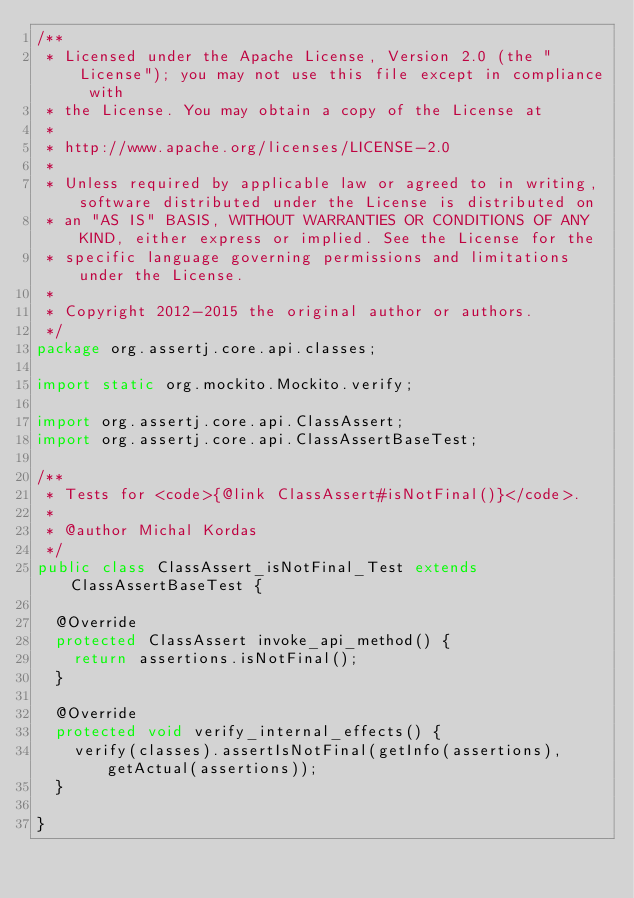Convert code to text. <code><loc_0><loc_0><loc_500><loc_500><_Java_>/**
 * Licensed under the Apache License, Version 2.0 (the "License"); you may not use this file except in compliance with
 * the License. You may obtain a copy of the License at
 *
 * http://www.apache.org/licenses/LICENSE-2.0
 *
 * Unless required by applicable law or agreed to in writing, software distributed under the License is distributed on
 * an "AS IS" BASIS, WITHOUT WARRANTIES OR CONDITIONS OF ANY KIND, either express or implied. See the License for the
 * specific language governing permissions and limitations under the License.
 *
 * Copyright 2012-2015 the original author or authors.
 */
package org.assertj.core.api.classes;

import static org.mockito.Mockito.verify;

import org.assertj.core.api.ClassAssert;
import org.assertj.core.api.ClassAssertBaseTest;

/**
 * Tests for <code>{@link ClassAssert#isNotFinal()}</code>.
 *
 * @author Michal Kordas
 */
public class ClassAssert_isNotFinal_Test extends ClassAssertBaseTest {

  @Override
  protected ClassAssert invoke_api_method() {
    return assertions.isNotFinal();
  }

  @Override
  protected void verify_internal_effects() {
    verify(classes).assertIsNotFinal(getInfo(assertions), getActual(assertions));
  }

}
</code> 